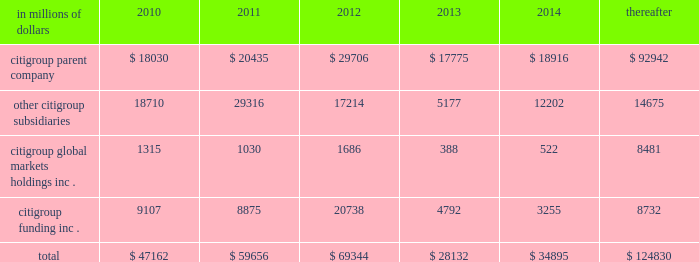Cgmhi also has substantial borrowing arrangements consisting of facilities that cgmhi has been advised are available , but where no contractual lending obligation exists .
These arrangements are reviewed on an ongoing basis to ensure flexibility in meeting cgmhi 2019s short-term requirements .
The company issues both fixed and variable rate debt in a range of currencies .
It uses derivative contracts , primarily interest rate swaps , to effectively convert a portion of its fixed rate debt to variable rate debt and variable rate debt to fixed rate debt .
The maturity structure of the derivatives generally corresponds to the maturity structure of the debt being hedged .
In addition , the company uses other derivative contracts to manage the foreign exchange impact of certain debt issuances .
At december 31 , 2009 , the company 2019s overall weighted average interest rate for long-term debt was 3.51% ( 3.51 % ) on a contractual basis and 3.91% ( 3.91 % ) including the effects of derivative contracts .
Aggregate annual maturities of long-term debt obligations ( based on final maturity dates ) including trust preferred securities are as follows: .
Long-term debt at december 31 , 2009 and december 31 , 2008 includes $ 19345 million and $ 24060 million , respectively , of junior subordinated debt .
The company formed statutory business trusts under the laws of the state of delaware .
The trusts exist for the exclusive purposes of ( i ) issuing trust securities representing undivided beneficial interests in the assets of the trust ; ( ii ) investing the gross proceeds of the trust securities in junior subordinated deferrable interest debentures ( subordinated debentures ) of its parent ; and ( iii ) engaging in only those activities necessary or incidental thereto .
Upon approval from the federal reserve , citigroup has the right to redeem these securities .
Citigroup has contractually agreed not to redeem or purchase ( i ) the 6.50% ( 6.50 % ) enhanced trust preferred securities of citigroup capital xv before september 15 , 2056 , ( ii ) the 6.45% ( 6.45 % ) enhanced trust preferred securities of citigroup capital xvi before december 31 , 2046 , ( iii ) the 6.35% ( 6.35 % ) enhanced trust preferred securities of citigroup capital xvii before march 15 , 2057 , ( iv ) the 6.829% ( 6.829 % ) fixed rate/floating rate enhanced trust preferred securities of citigroup capital xviii before june 28 , 2047 , ( v ) the 7.250% ( 7.250 % ) enhanced trust preferred securities of citigroup capital xix before august 15 , 2047 , ( vi ) the 7.875% ( 7.875 % ) enhanced trust preferred securities of citigroup capital xx before december 15 , 2067 , and ( vii ) the 8.300% ( 8.300 % ) fixed rate/floating rate enhanced trust preferred securities of citigroup capital xxi before december 21 , 2067 , unless certain conditions , described in exhibit 4.03 to citigroup 2019s current report on form 8-k filed on september 18 , 2006 , in exhibit 4.02 to citigroup 2019s current report on form 8-k filed on november 28 , 2006 , in exhibit 4.02 to citigroup 2019s current report on form 8-k filed on march 8 , 2007 , in exhibit 4.02 to citigroup 2019s current report on form 8-k filed on july 2 , 2007 , in exhibit 4.02 to citigroup 2019s current report on form 8-k filed on august 17 , 2007 , in exhibit 4.2 to citigroup 2019s current report on form 8-k filed on november 27 , 2007 , and in exhibit 4.2 to citigroup 2019s current report on form 8-k filed on december 21 , 2007 , respectively , are met .
These agreements are for the benefit of the holders of citigroup 2019s 6.00% ( 6.00 % ) junior subordinated deferrable interest debentures due 2034 .
Citigroup owns all of the voting securities of these subsidiary trusts .
These subsidiary trusts have no assets , operations , revenues or cash flows other than those related to the issuance , administration , and repayment of the subsidiary trusts and the subsidiary trusts 2019 common securities .
These subsidiary trusts 2019 obligations are fully and unconditionally guaranteed by citigroup. .
What was the percent of the long-term debt junior subordinated debt and at december 31 , 2009 compared to december 31 , 2008? 
Rationale: the percent of the long-term debt junior subordinated debt and at december 31 , 2009 was equal to 80.4% of the december 31 , 2008 junior subordinated debt
Computations: (19345 / 24060)
Answer: 0.80403. 